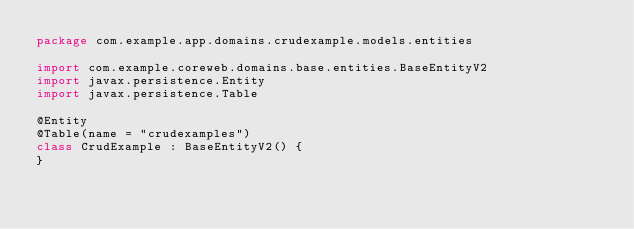<code> <loc_0><loc_0><loc_500><loc_500><_Kotlin_>package com.example.app.domains.crudexample.models.entities

import com.example.coreweb.domains.base.entities.BaseEntityV2
import javax.persistence.Entity
import javax.persistence.Table

@Entity
@Table(name = "crudexamples")
class CrudExample : BaseEntityV2() {
}</code> 